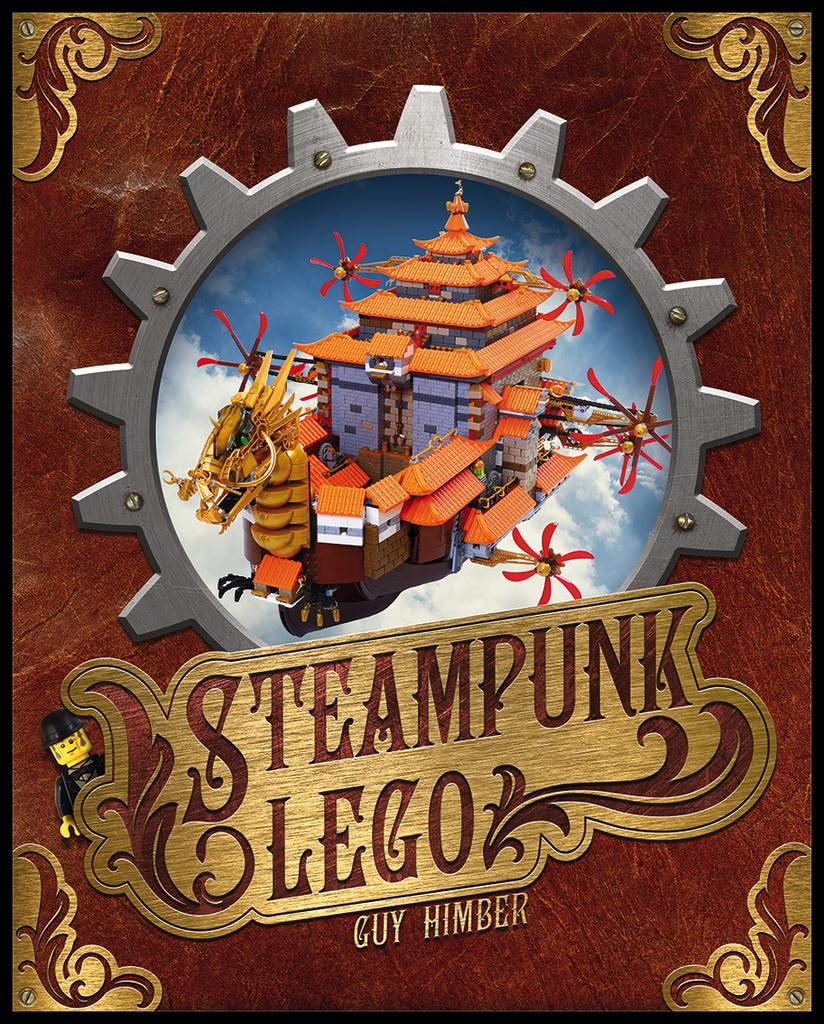<image>
Give a short and clear explanation of the subsequent image. A poster of legos titled Steampunk Lego by Guy Himber 